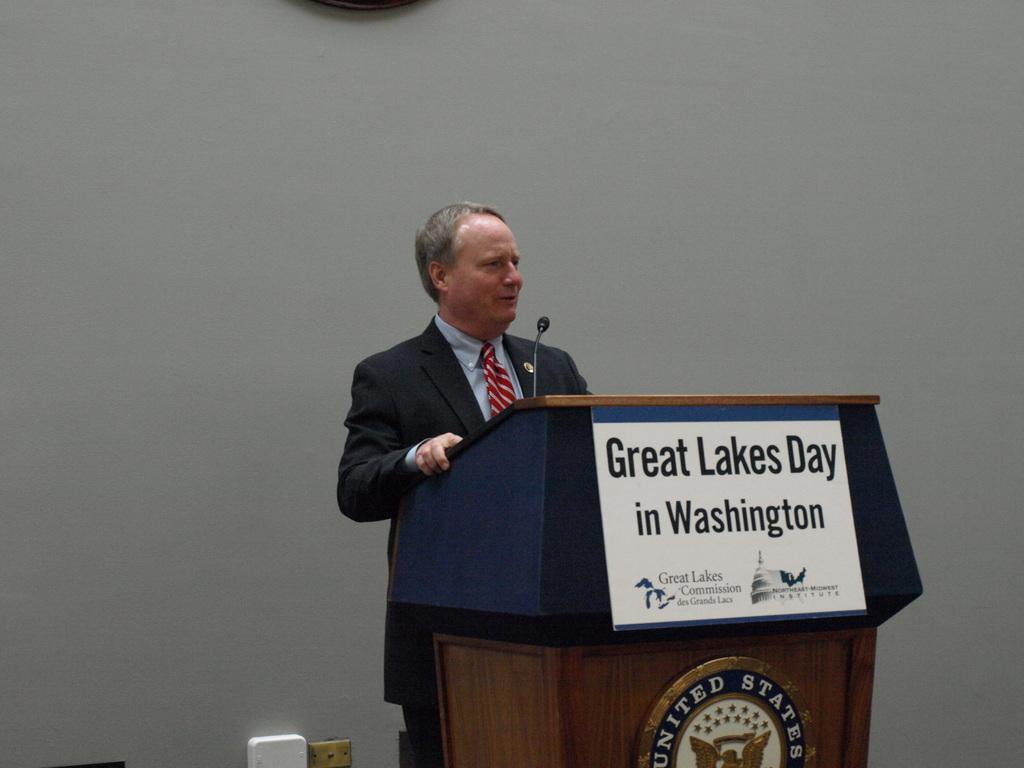What day is it?
Make the answer very short. Great lakes day. Does the sign on the podium say great lakes day in washington?
Offer a very short reply. Yes. 